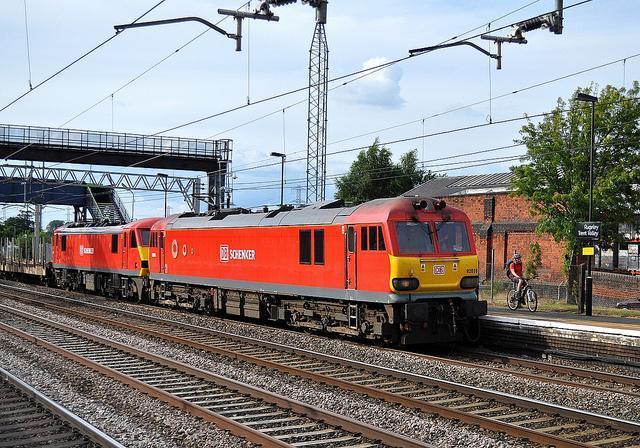How many tracks do you see?
Give a very brief answer. 4. 